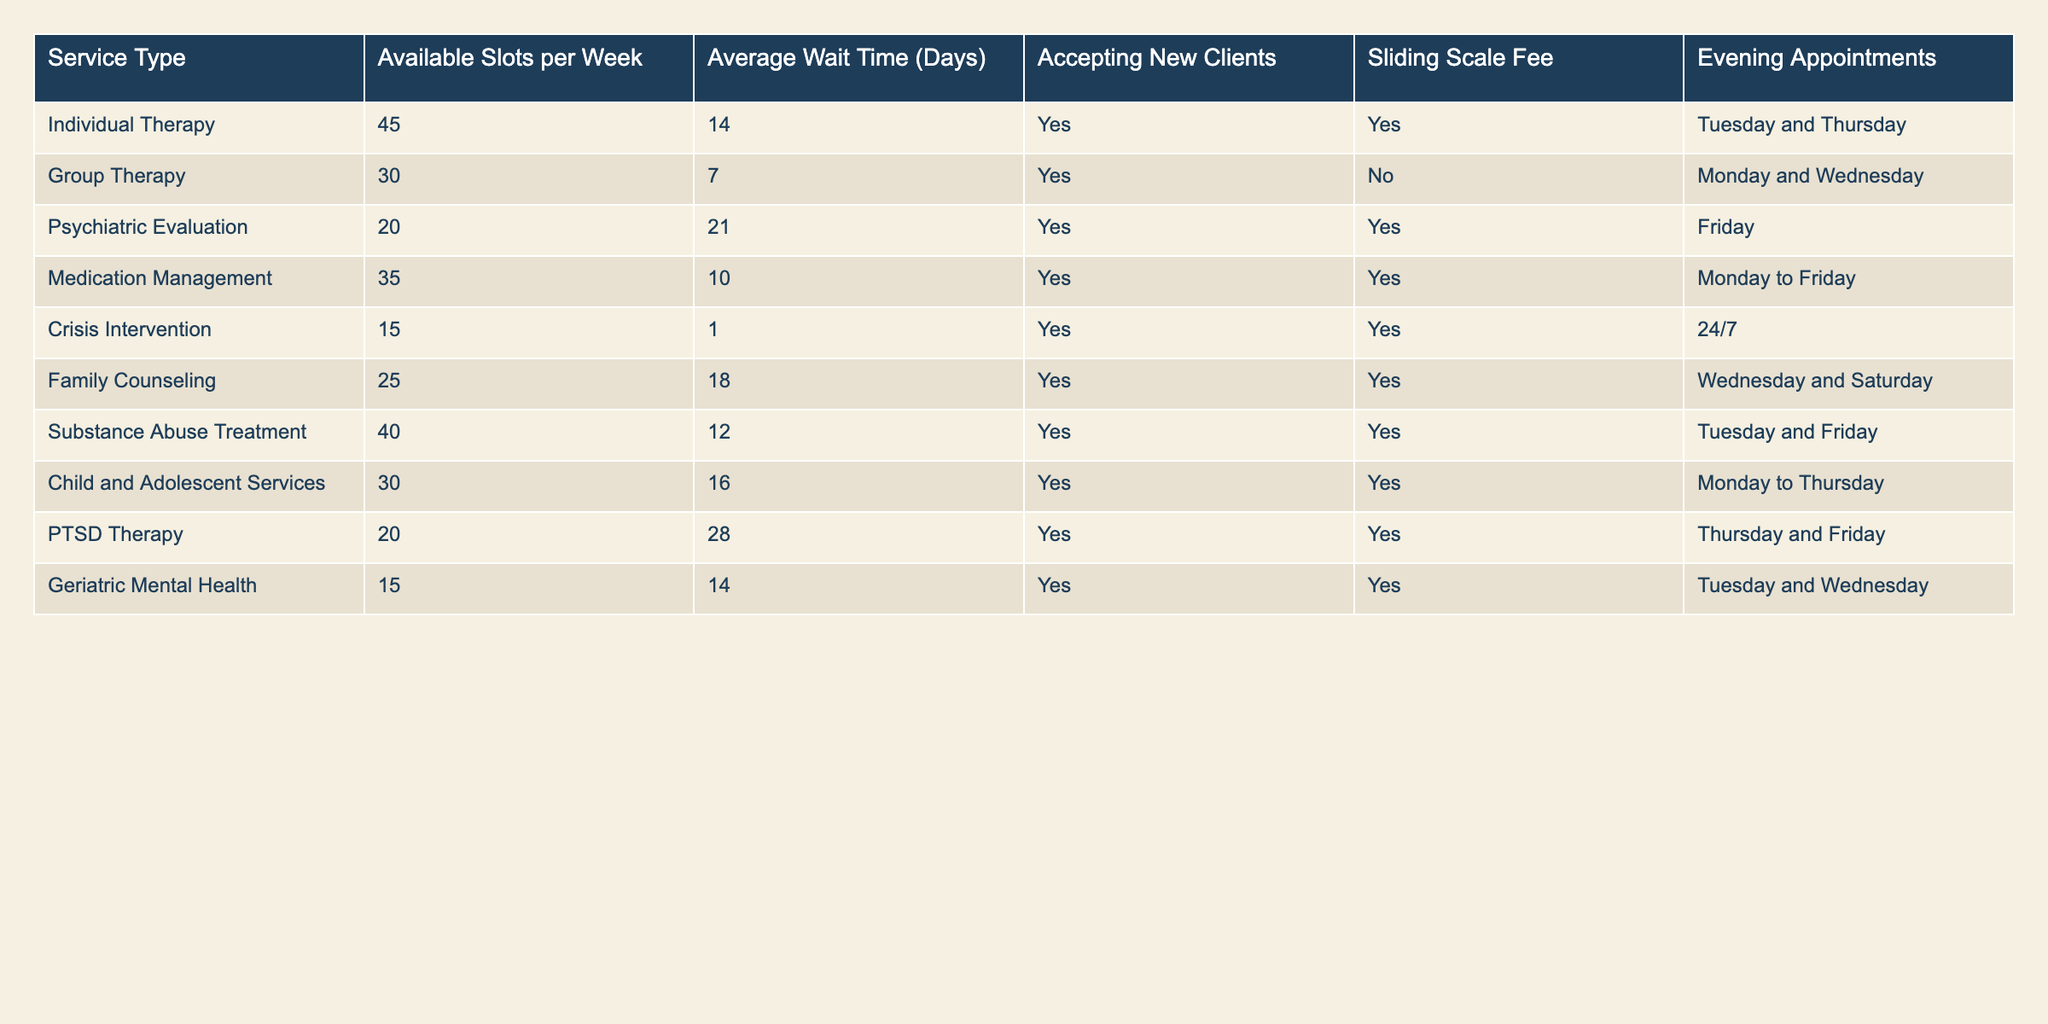What is the average wait time for all services? To find the average wait time, we add up all the average wait times: 14 + 7 + 21 + 10 + 1 + 18 + 12 + 16 + 28 + 14 =  14 + 7 + 21 + 10 + 1 + 18 + 12 + 16 + 28 + 14 =  14 + 7 + 21 + 10 + 1 + 18 + 12 + 16 + 28 + 14 = 141. There are 10 services, so we divide 141 by 10 to get the average, which is 14.1 days
Answer: 14.1 days Which service has the longest average wait time? The wait times for each service are: Individual Therapy 14, Group Therapy 7, Psychiatric Evaluation 21, Medication Management 10, Crisis Intervention 1, Family Counseling 18, Substance Abuse Treatment 12, Child and Adolescent Services 16, PTSD Therapy 28, Geriatric Mental Health 14. The longest wait time is 28 days for PTSD Therapy.
Answer: PTSD Therapy Are there any services that offer sliding scale fees? We look at the "Sliding Scale Fee" column: Individual Therapy, Psychiatric Evaluation, Crisis Intervention, Family Counseling, Substance Abuse Treatment, Child and Adolescent Services, and Geriatric Mental Health all have 'Yes' listed. Therefore, there are services available that offer sliding scale fees.
Answer: Yes What is the total number of available slots for therapy services each week? Sum the available slots for therapy services: 45 (Individual Therapy) + 30 (Group Therapy) + 35 (Medication Management) + 40 (Substance Abuse Treatment) + 30 (Child and Adolescent Services) = 210 slots available per week.
Answer: 210 slots Which day has the most evening appointments available? We check the evening appointment days for each service: Individual Therapy (Tuesday and Thursday), Group Therapy (Monday and Wednesday), Medication Management (Monday to Friday), Substance Abuse Treatment (Tuesday and Friday), Child and Adolescent Services (Monday to Thursday), PTSD Therapy (Thursday and Friday), Geriatric Mental Health (Tuesday and Wednesday). Count the occurrences for each day: Monday (4), Tuesday (4), Wednesday (4), Thursday (4), Friday (3). Each day has the same number of appointments (4), so no single day has more; they are all equal in evening appointments.
Answer: Monday, Tuesday, Wednesday, Thursday Is Family Counseling accepting new clients? The "Accepting New Clients" column indicates that Family Counseling has a 'Yes' value listed. Therefore, Family Counseling is accepting new clients.
Answer: Yes What services are available on Thursday? The services available on Thursday are Individual Therapy and PTSD Therapy.
Answer: Individual Therapy, PTSD Therapy How many services have an average wait time of more than 14 days? Looking at the average wait times: Psychiatric Evaluation (21), Family Counseling (18), PTSD Therapy (28). There are 3 services that have wait times more than 14 days.
Answer: 3 services Which service provides crisis intervention and what are its available slots? The table indicates that Crisis Intervention is a service type, and it has 15 available slots per week.
Answer: 15 slots How many services have evening appointments available only on weekdays? The services with evening appointments only on weekdays are Individual Therapy, Medication Management, and Substance Abuse Treatment. Counting these services gives us a total of 3 services.
Answer: 3 services 